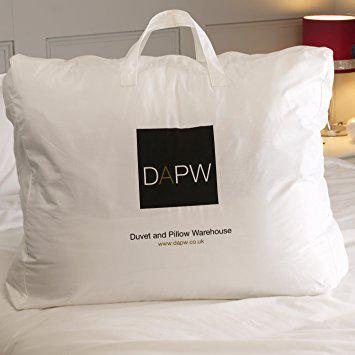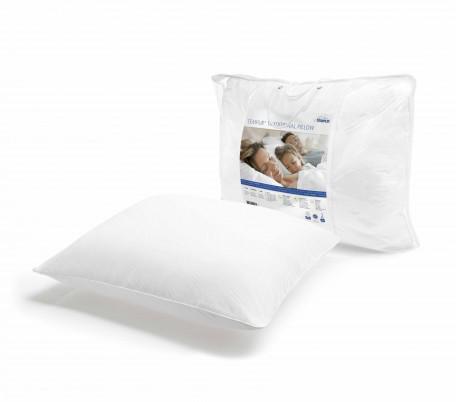The first image is the image on the left, the second image is the image on the right. For the images shown, is this caption "We see one pillow in the image on the right." true? Answer yes or no. No. 